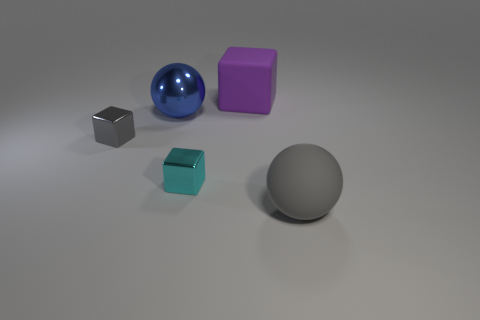Add 1 big yellow metallic cubes. How many objects exist? 6 Subtract all small cubes. How many cubes are left? 1 Subtract all balls. How many objects are left? 3 Add 5 green metal cubes. How many green metal cubes exist? 5 Subtract 0 red blocks. How many objects are left? 5 Subtract all blue spheres. Subtract all yellow blocks. How many spheres are left? 1 Subtract all blue shiny balls. Subtract all tiny blocks. How many objects are left? 2 Add 1 large purple cubes. How many large purple cubes are left? 2 